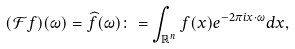<formula> <loc_0><loc_0><loc_500><loc_500>( \mathcal { F } f ) ( \omega ) = \widehat { f } ( \omega ) \colon = \int _ { \mathbb { R } ^ { n } } f ( x ) e ^ { - 2 \pi i x \cdot \omega } d x ,</formula> 